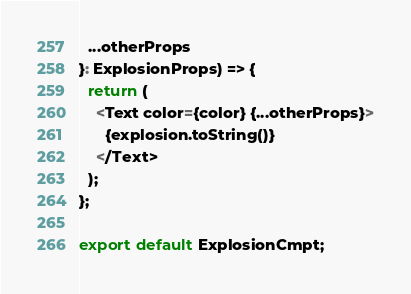<code> <loc_0><loc_0><loc_500><loc_500><_TypeScript_>  ...otherProps
}: ExplosionProps) => {
  return (
    <Text color={color} {...otherProps}>
      {explosion.toString()}
    </Text>
  );
};

export default ExplosionCmpt;
</code> 